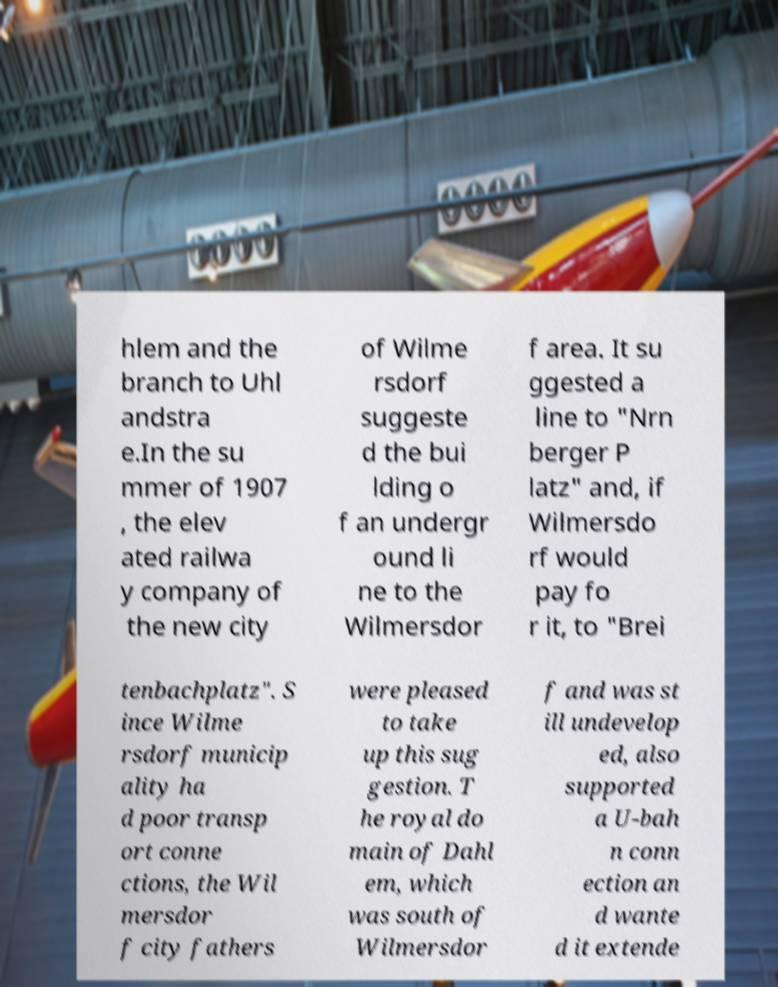Please read and relay the text visible in this image. What does it say? hlem and the branch to Uhl andstra e.In the su mmer of 1907 , the elev ated railwa y company of the new city of Wilme rsdorf suggeste d the bui lding o f an undergr ound li ne to the Wilmersdor f area. It su ggested a line to "Nrn berger P latz" and, if Wilmersdo rf would pay fo r it, to "Brei tenbachplatz". S ince Wilme rsdorf municip ality ha d poor transp ort conne ctions, the Wil mersdor f city fathers were pleased to take up this sug gestion. T he royal do main of Dahl em, which was south of Wilmersdor f and was st ill undevelop ed, also supported a U-bah n conn ection an d wante d it extende 